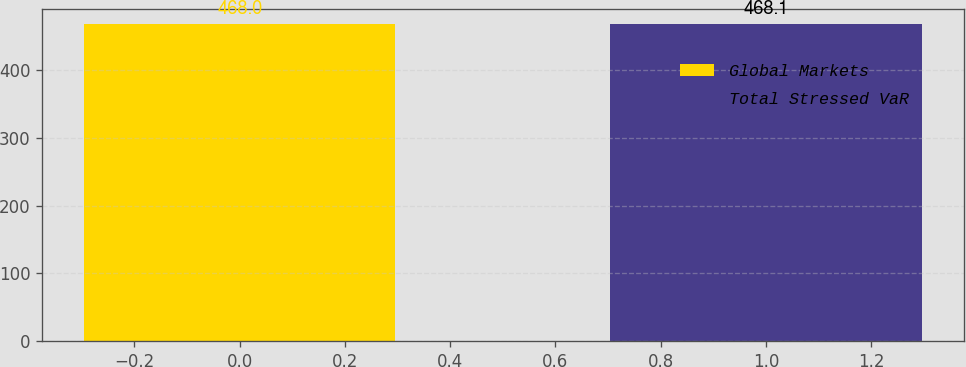<chart> <loc_0><loc_0><loc_500><loc_500><bar_chart><fcel>Global Markets<fcel>Total Stressed VaR<nl><fcel>468<fcel>468.1<nl></chart> 